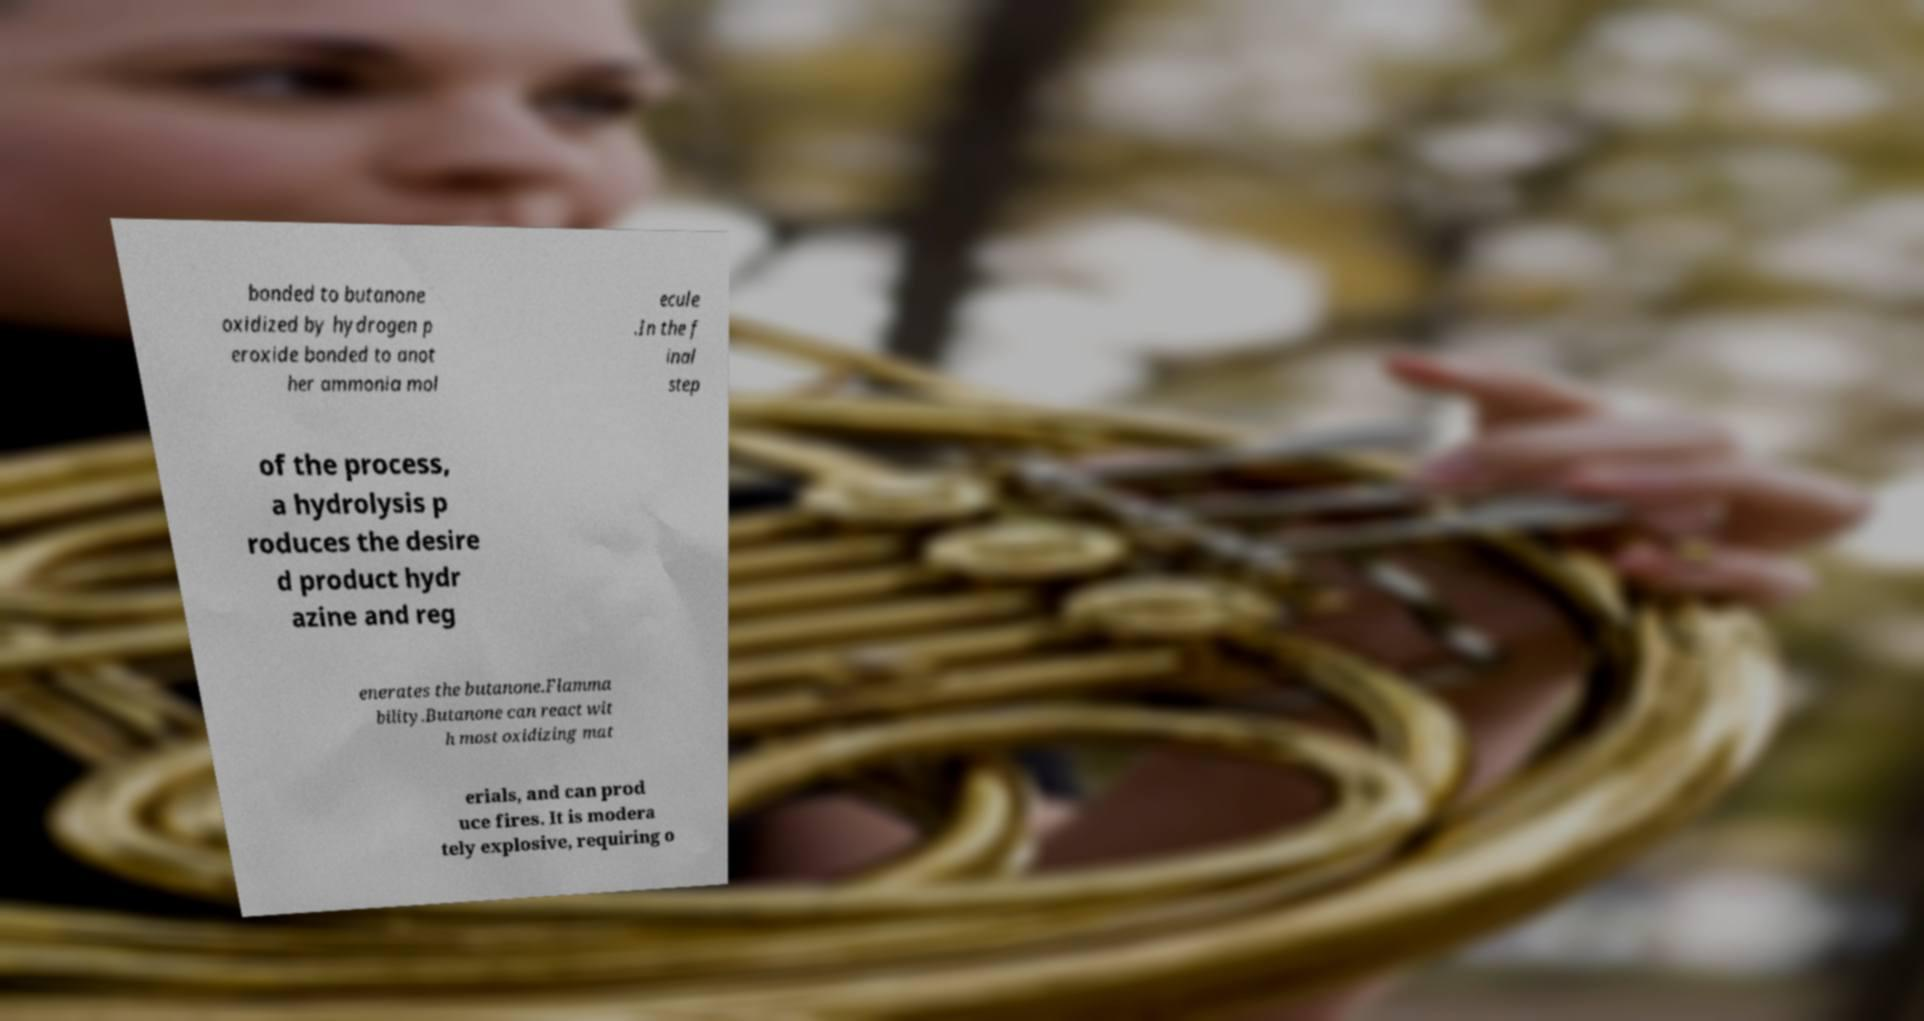There's text embedded in this image that I need extracted. Can you transcribe it verbatim? bonded to butanone oxidized by hydrogen p eroxide bonded to anot her ammonia mol ecule .In the f inal step of the process, a hydrolysis p roduces the desire d product hydr azine and reg enerates the butanone.Flamma bility.Butanone can react wit h most oxidizing mat erials, and can prod uce fires. It is modera tely explosive, requiring o 